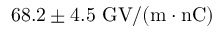Convert formula to latex. <formula><loc_0><loc_0><loc_500><loc_500>6 8 . 2 \pm 4 . 5 G V / ( m \cdot n C )</formula> 